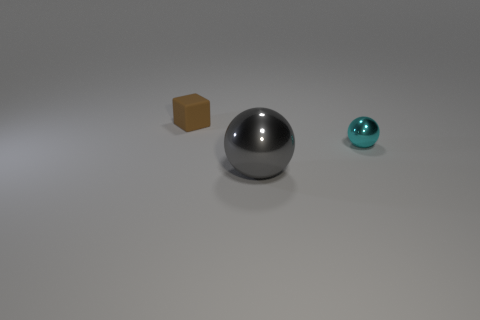Is the number of cyan balls to the right of the small cube the same as the number of gray things behind the gray object?
Keep it short and to the point. No. What number of cyan balls are there?
Your answer should be compact. 1. Are there more big gray metal things behind the big gray ball than large blue metal objects?
Your response must be concise. No. There is a tiny thing that is left of the cyan metal object; what is it made of?
Keep it short and to the point. Rubber. What color is the other metallic object that is the same shape as the cyan object?
Offer a very short reply. Gray. What number of large objects are the same color as the large shiny sphere?
Give a very brief answer. 0. There is a sphere that is on the left side of the cyan thing; is its size the same as the object behind the small ball?
Your answer should be compact. No. There is a cyan thing; does it have the same size as the ball that is in front of the small metallic thing?
Your answer should be very brief. No. The cyan metallic ball is what size?
Offer a terse response. Small. There is a small object that is made of the same material as the big gray thing; what color is it?
Keep it short and to the point. Cyan. 